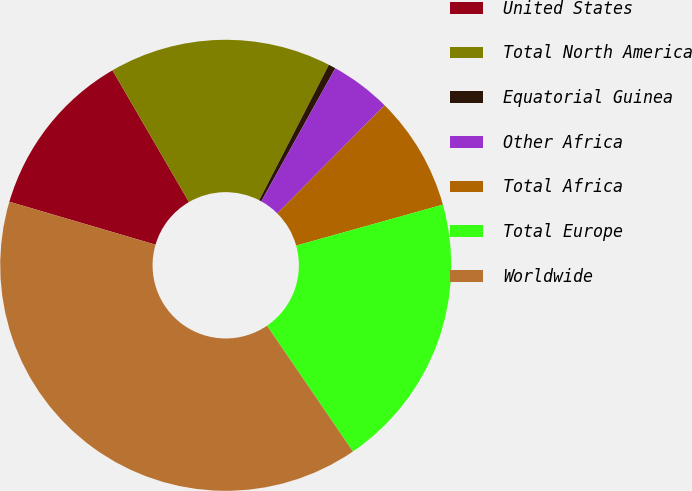<chart> <loc_0><loc_0><loc_500><loc_500><pie_chart><fcel>United States<fcel>Total North America<fcel>Equatorial Guinea<fcel>Other Africa<fcel>Total Africa<fcel>Total Europe<fcel>Worldwide<nl><fcel>12.08%<fcel>15.94%<fcel>0.51%<fcel>4.37%<fcel>8.22%<fcel>19.8%<fcel>39.09%<nl></chart> 